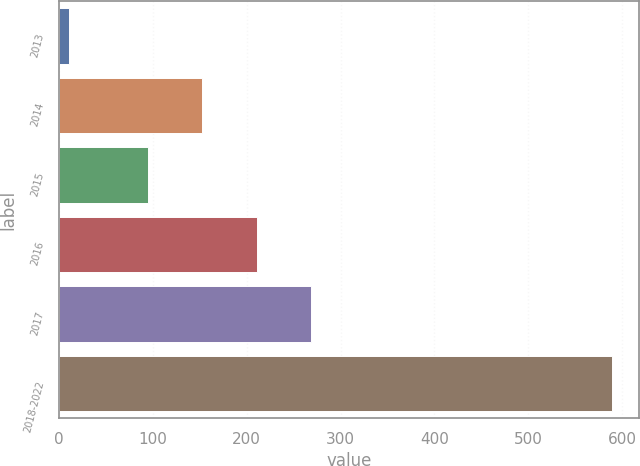<chart> <loc_0><loc_0><loc_500><loc_500><bar_chart><fcel>2013<fcel>2014<fcel>2015<fcel>2016<fcel>2017<fcel>2018-2022<nl><fcel>11<fcel>152.8<fcel>95<fcel>210.6<fcel>268.4<fcel>589<nl></chart> 